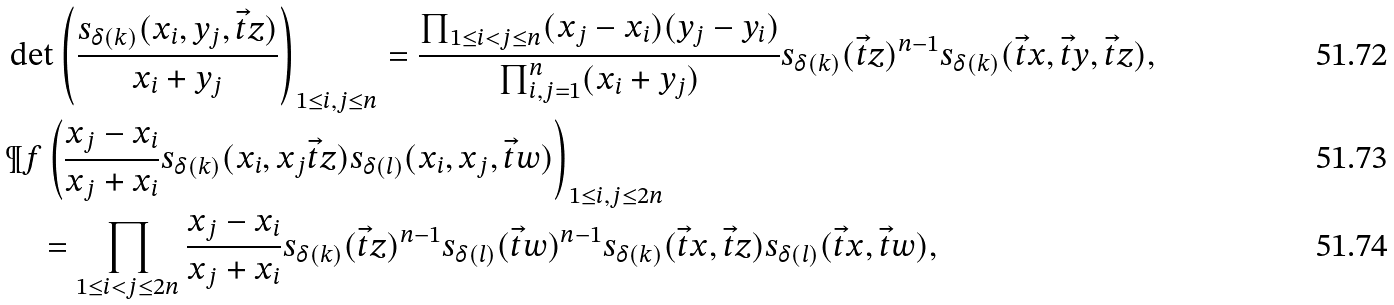Convert formula to latex. <formula><loc_0><loc_0><loc_500><loc_500>& \det \left ( \frac { s _ { \delta ( k ) } ( x _ { i } , y _ { j } , \vec { t } z ) } { x _ { i } + y _ { j } } \right ) _ { 1 \leq i , j \leq n } = \frac { \prod _ { 1 \leq i < j \leq n } ( x _ { j } - x _ { i } ) ( y _ { j } - y _ { i } ) } { \prod _ { i , j = 1 } ^ { n } ( x _ { i } + y _ { j } ) } s _ { \delta ( k ) } ( \vec { t } z ) ^ { n - 1 } s _ { \delta ( k ) } ( \vec { t } x , \vec { t } y , \vec { t } z ) , \\ & \P f \left ( \frac { x _ { j } - x _ { i } } { x _ { j } + x _ { i } } s _ { \delta ( k ) } ( x _ { i } , x _ { j } \vec { t } z ) s _ { \delta ( l ) } ( x _ { i } , x _ { j } , \vec { t } w ) \right ) _ { 1 \leq i , j \leq 2 n } \\ & \quad = \prod _ { 1 \leq i < j \leq 2 n } \frac { x _ { j } - x _ { i } } { x _ { j } + x _ { i } } s _ { \delta ( k ) } ( \vec { t } z ) ^ { n - 1 } s _ { \delta ( l ) } ( \vec { t } w ) ^ { n - 1 } s _ { \delta ( k ) } ( \vec { t } x , \vec { t } z ) s _ { \delta ( l ) } ( \vec { t } x , \vec { t } w ) ,</formula> 